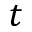Convert formula to latex. <formula><loc_0><loc_0><loc_500><loc_500>t</formula> 